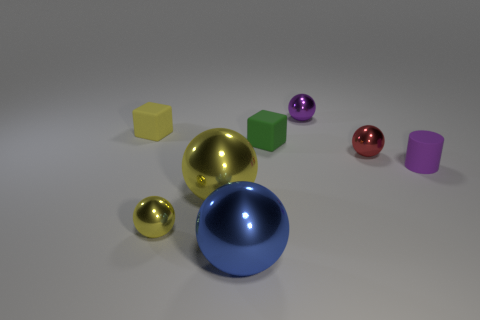What is the size of the purple object that is behind the yellow object that is behind the red metallic ball?
Your answer should be very brief. Small. Does the tiny cylinder have the same color as the tiny ball that is behind the small red shiny thing?
Your answer should be compact. Yes. Is there a blue sphere of the same size as the purple cylinder?
Provide a succinct answer. No. What size is the yellow thing behind the small green thing?
Make the answer very short. Small. Is there a large blue thing that is to the right of the tiny matte block that is on the right side of the big blue metallic ball?
Make the answer very short. No. How many other things are the same shape as the big blue thing?
Make the answer very short. 4. Is the red object the same shape as the tiny yellow rubber object?
Give a very brief answer. No. What color is the sphere that is both behind the tiny yellow shiny ball and in front of the rubber cylinder?
Provide a short and direct response. Yellow. What is the size of the sphere that is the same color as the tiny cylinder?
Keep it short and to the point. Small. What number of small objects are either objects or blue metal things?
Give a very brief answer. 6. 